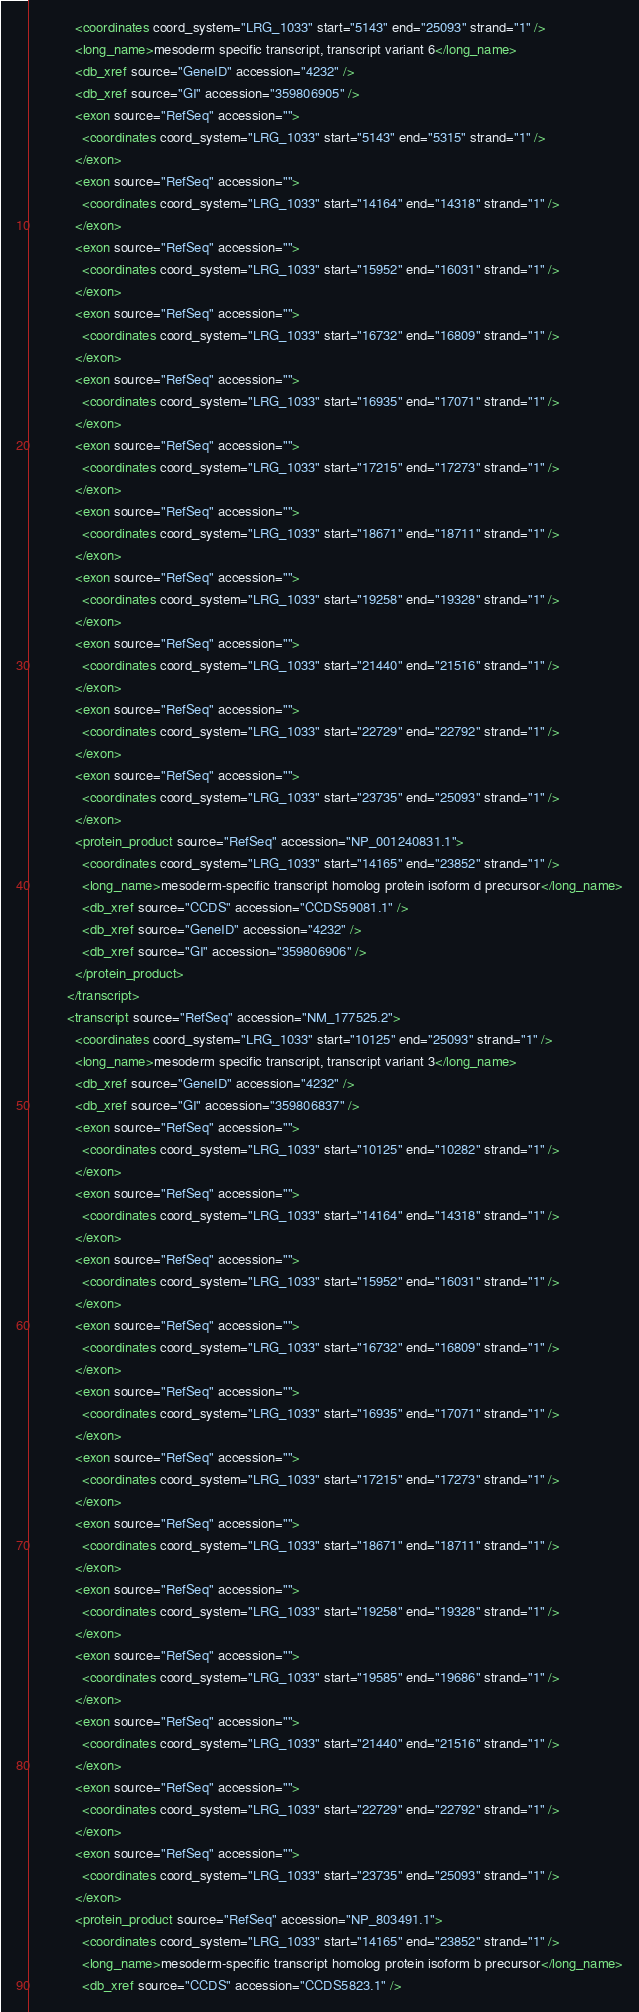<code> <loc_0><loc_0><loc_500><loc_500><_XML_>            <coordinates coord_system="LRG_1033" start="5143" end="25093" strand="1" />
            <long_name>mesoderm specific transcript, transcript variant 6</long_name>
            <db_xref source="GeneID" accession="4232" />
            <db_xref source="GI" accession="359806905" />
            <exon source="RefSeq" accession="">
              <coordinates coord_system="LRG_1033" start="5143" end="5315" strand="1" />
            </exon>
            <exon source="RefSeq" accession="">
              <coordinates coord_system="LRG_1033" start="14164" end="14318" strand="1" />
            </exon>
            <exon source="RefSeq" accession="">
              <coordinates coord_system="LRG_1033" start="15952" end="16031" strand="1" />
            </exon>
            <exon source="RefSeq" accession="">
              <coordinates coord_system="LRG_1033" start="16732" end="16809" strand="1" />
            </exon>
            <exon source="RefSeq" accession="">
              <coordinates coord_system="LRG_1033" start="16935" end="17071" strand="1" />
            </exon>
            <exon source="RefSeq" accession="">
              <coordinates coord_system="LRG_1033" start="17215" end="17273" strand="1" />
            </exon>
            <exon source="RefSeq" accession="">
              <coordinates coord_system="LRG_1033" start="18671" end="18711" strand="1" />
            </exon>
            <exon source="RefSeq" accession="">
              <coordinates coord_system="LRG_1033" start="19258" end="19328" strand="1" />
            </exon>
            <exon source="RefSeq" accession="">
              <coordinates coord_system="LRG_1033" start="21440" end="21516" strand="1" />
            </exon>
            <exon source="RefSeq" accession="">
              <coordinates coord_system="LRG_1033" start="22729" end="22792" strand="1" />
            </exon>
            <exon source="RefSeq" accession="">
              <coordinates coord_system="LRG_1033" start="23735" end="25093" strand="1" />
            </exon>
            <protein_product source="RefSeq" accession="NP_001240831.1">
              <coordinates coord_system="LRG_1033" start="14165" end="23852" strand="1" />
              <long_name>mesoderm-specific transcript homolog protein isoform d precursor</long_name>
              <db_xref source="CCDS" accession="CCDS59081.1" />
              <db_xref source="GeneID" accession="4232" />
              <db_xref source="GI" accession="359806906" />
            </protein_product>
          </transcript>
          <transcript source="RefSeq" accession="NM_177525.2">
            <coordinates coord_system="LRG_1033" start="10125" end="25093" strand="1" />
            <long_name>mesoderm specific transcript, transcript variant 3</long_name>
            <db_xref source="GeneID" accession="4232" />
            <db_xref source="GI" accession="359806837" />
            <exon source="RefSeq" accession="">
              <coordinates coord_system="LRG_1033" start="10125" end="10282" strand="1" />
            </exon>
            <exon source="RefSeq" accession="">
              <coordinates coord_system="LRG_1033" start="14164" end="14318" strand="1" />
            </exon>
            <exon source="RefSeq" accession="">
              <coordinates coord_system="LRG_1033" start="15952" end="16031" strand="1" />
            </exon>
            <exon source="RefSeq" accession="">
              <coordinates coord_system="LRG_1033" start="16732" end="16809" strand="1" />
            </exon>
            <exon source="RefSeq" accession="">
              <coordinates coord_system="LRG_1033" start="16935" end="17071" strand="1" />
            </exon>
            <exon source="RefSeq" accession="">
              <coordinates coord_system="LRG_1033" start="17215" end="17273" strand="1" />
            </exon>
            <exon source="RefSeq" accession="">
              <coordinates coord_system="LRG_1033" start="18671" end="18711" strand="1" />
            </exon>
            <exon source="RefSeq" accession="">
              <coordinates coord_system="LRG_1033" start="19258" end="19328" strand="1" />
            </exon>
            <exon source="RefSeq" accession="">
              <coordinates coord_system="LRG_1033" start="19585" end="19686" strand="1" />
            </exon>
            <exon source="RefSeq" accession="">
              <coordinates coord_system="LRG_1033" start="21440" end="21516" strand="1" />
            </exon>
            <exon source="RefSeq" accession="">
              <coordinates coord_system="LRG_1033" start="22729" end="22792" strand="1" />
            </exon>
            <exon source="RefSeq" accession="">
              <coordinates coord_system="LRG_1033" start="23735" end="25093" strand="1" />
            </exon>
            <protein_product source="RefSeq" accession="NP_803491.1">
              <coordinates coord_system="LRG_1033" start="14165" end="23852" strand="1" />
              <long_name>mesoderm-specific transcript homolog protein isoform b precursor</long_name>
              <db_xref source="CCDS" accession="CCDS5823.1" /></code> 